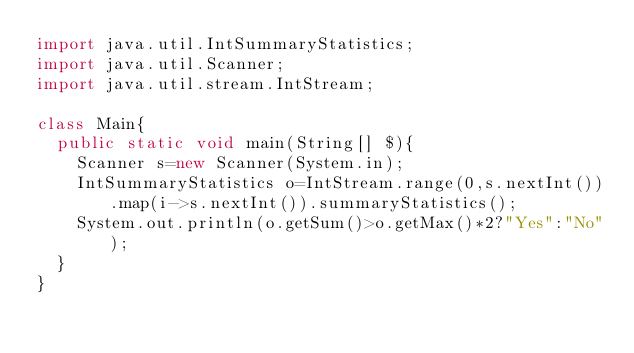<code> <loc_0><loc_0><loc_500><loc_500><_Java_>import java.util.IntSummaryStatistics;
import java.util.Scanner;
import java.util.stream.IntStream;

class Main{
	public static void main(String[] $){
		Scanner s=new Scanner(System.in);
		IntSummaryStatistics o=IntStream.range(0,s.nextInt()).map(i->s.nextInt()).summaryStatistics();
		System.out.println(o.getSum()>o.getMax()*2?"Yes":"No");
	}
}</code> 